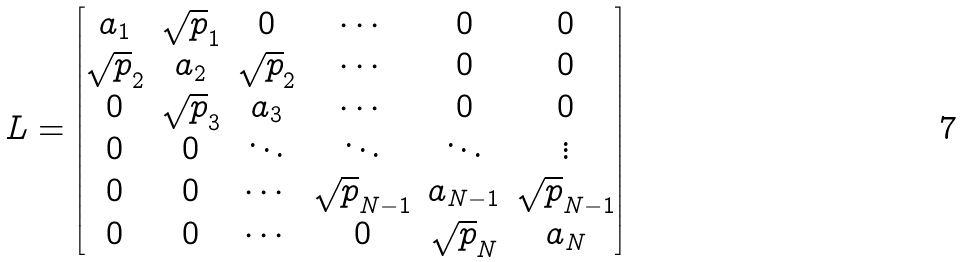<formula> <loc_0><loc_0><loc_500><loc_500>L = \begin{bmatrix} a _ { 1 } & \sqrt { p } _ { 1 } & 0 & \cdots & 0 & 0 \\ \sqrt { p } _ { 2 } & a _ { 2 } & \sqrt { p } _ { 2 } & \cdots & 0 & 0 \\ 0 & \sqrt { p } _ { 3 } & a _ { 3 } & \cdots & 0 & 0 \\ 0 & 0 & \ddots & \ddots & \ddots & \vdots \\ 0 & 0 & \cdots & \sqrt { p } _ { N - 1 } & a _ { N - 1 } & \sqrt { p } _ { N - 1 } \\ 0 & 0 & \cdots & 0 & \sqrt { p } _ { N } & a _ { N } \end{bmatrix}</formula> 